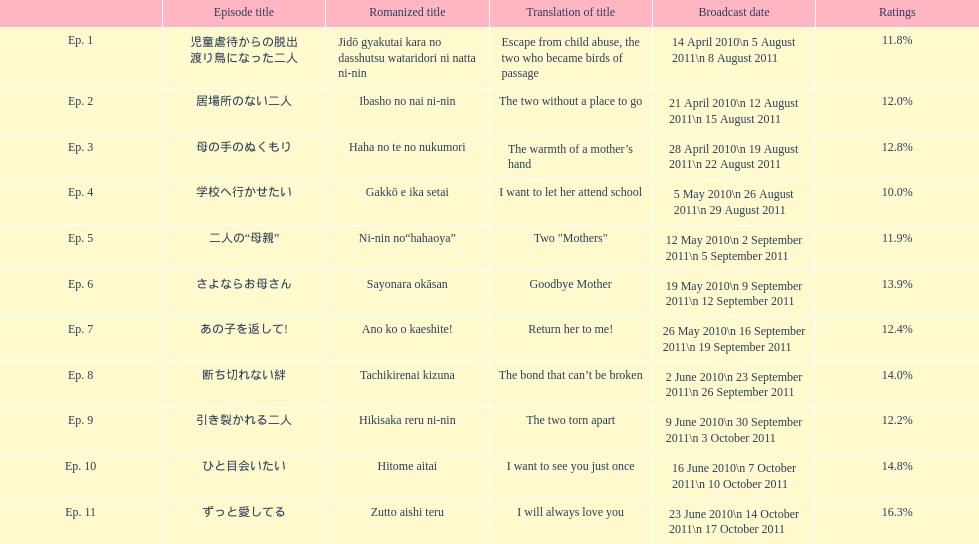What is the total number of episodes listed? 11. 